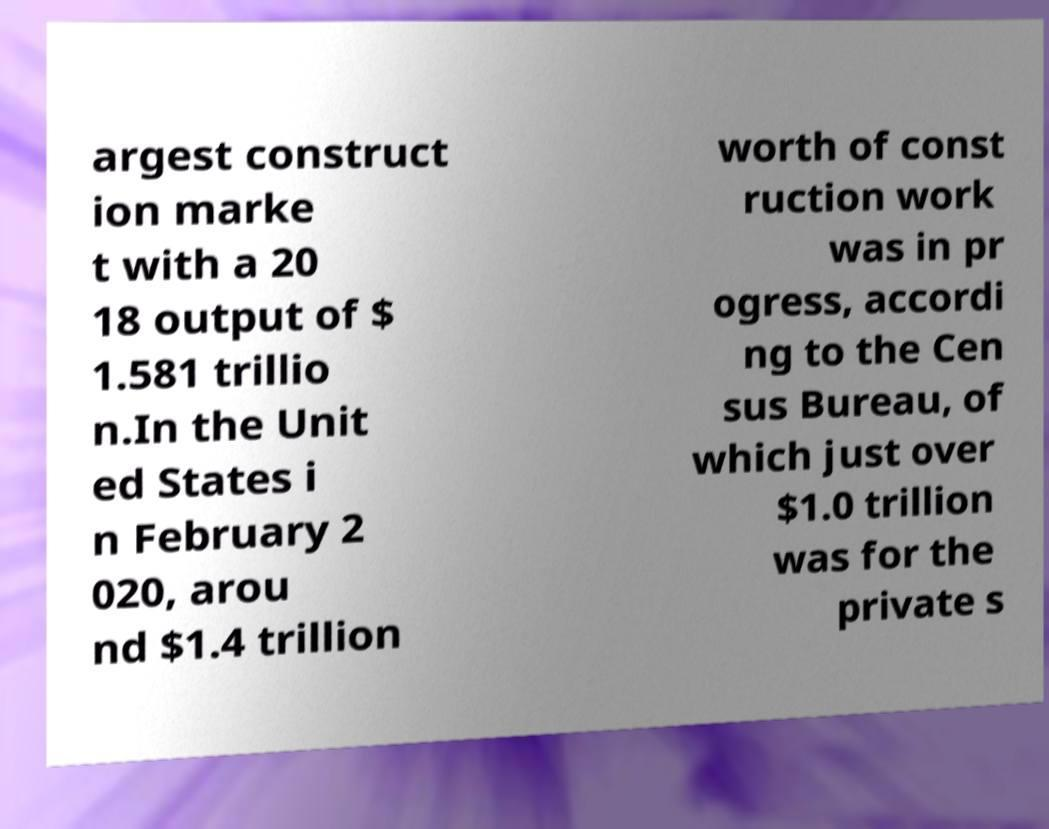Can you read and provide the text displayed in the image?This photo seems to have some interesting text. Can you extract and type it out for me? argest construct ion marke t with a 20 18 output of $ 1.581 trillio n.In the Unit ed States i n February 2 020, arou nd $1.4 trillion worth of const ruction work was in pr ogress, accordi ng to the Cen sus Bureau, of which just over $1.0 trillion was for the private s 